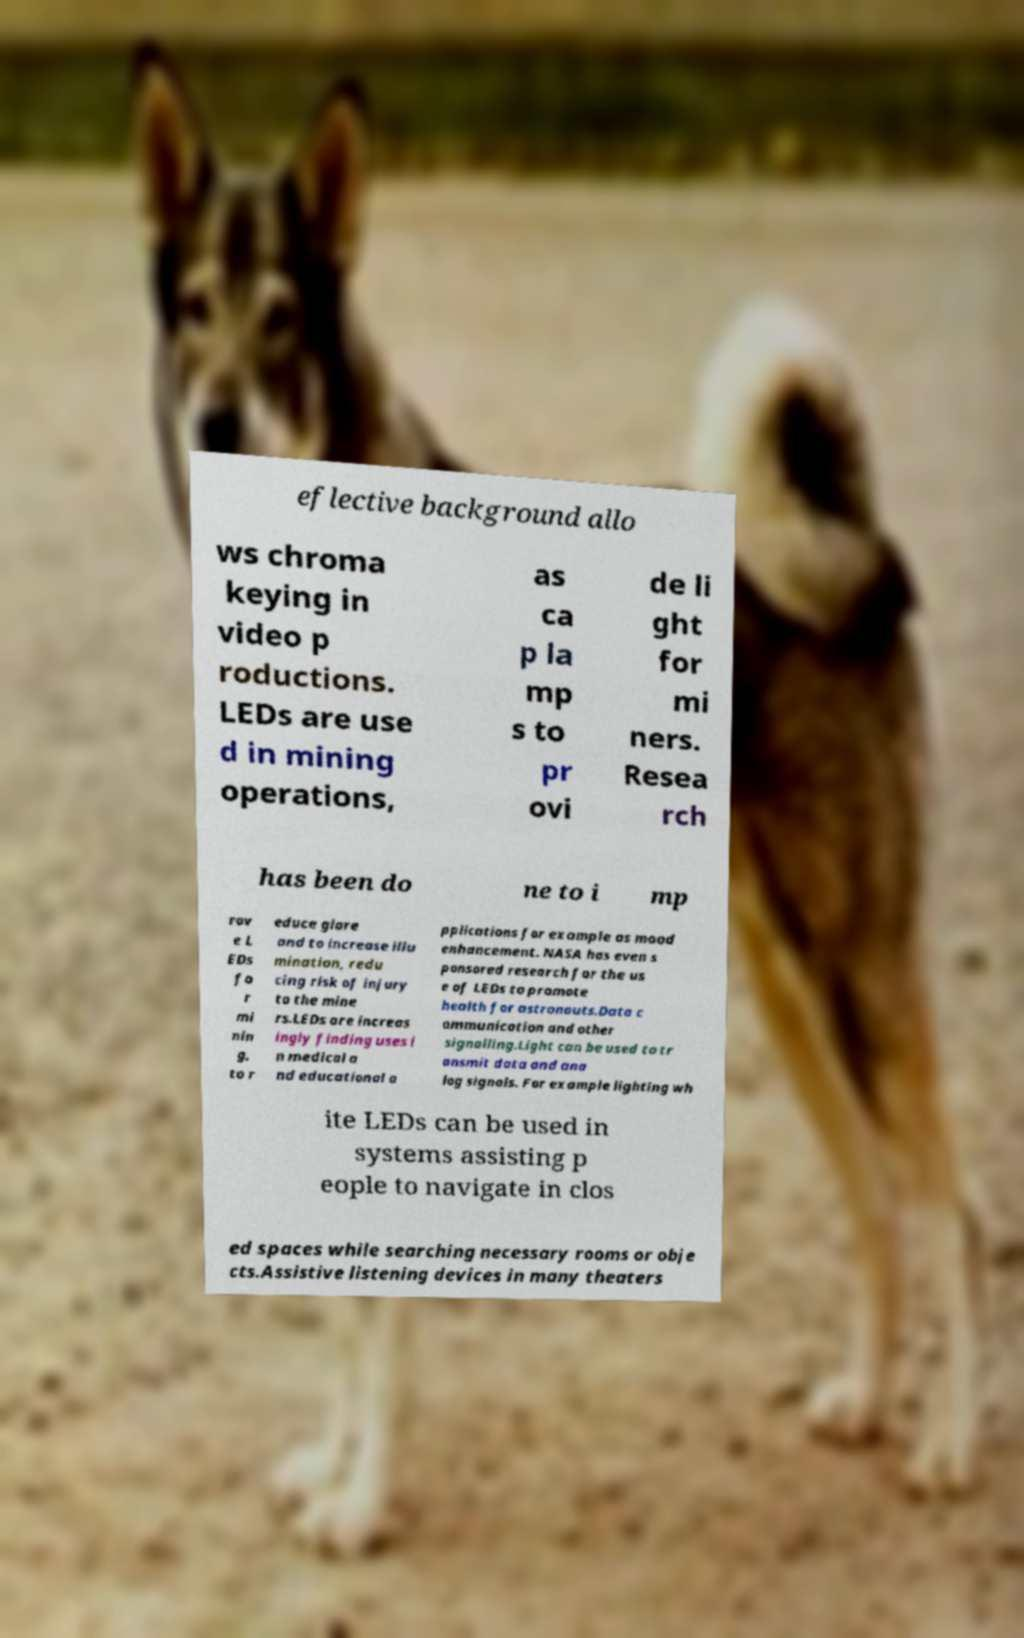Please identify and transcribe the text found in this image. eflective background allo ws chroma keying in video p roductions. LEDs are use d in mining operations, as ca p la mp s to pr ovi de li ght for mi ners. Resea rch has been do ne to i mp rov e L EDs fo r mi nin g, to r educe glare and to increase illu mination, redu cing risk of injury to the mine rs.LEDs are increas ingly finding uses i n medical a nd educational a pplications for example as mood enhancement. NASA has even s ponsored research for the us e of LEDs to promote health for astronauts.Data c ommunication and other signalling.Light can be used to tr ansmit data and ana log signals. For example lighting wh ite LEDs can be used in systems assisting p eople to navigate in clos ed spaces while searching necessary rooms or obje cts.Assistive listening devices in many theaters 